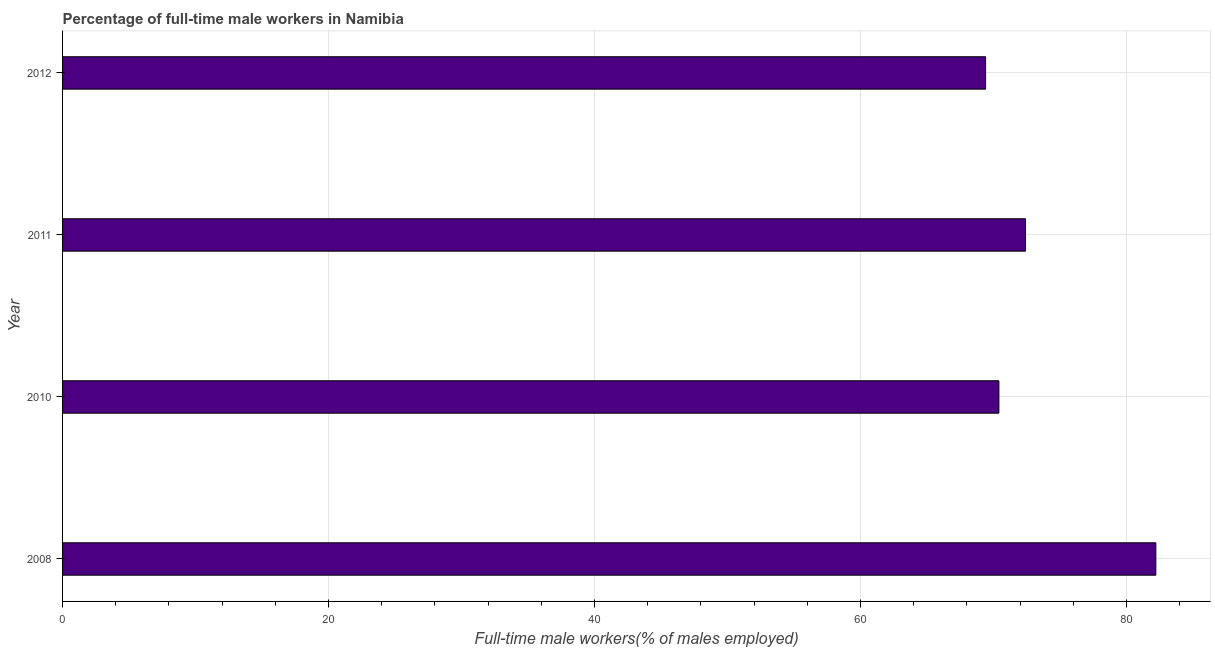Does the graph contain any zero values?
Keep it short and to the point. No. What is the title of the graph?
Make the answer very short. Percentage of full-time male workers in Namibia. What is the label or title of the X-axis?
Your response must be concise. Full-time male workers(% of males employed). What is the percentage of full-time male workers in 2012?
Make the answer very short. 69.4. Across all years, what is the maximum percentage of full-time male workers?
Ensure brevity in your answer.  82.2. Across all years, what is the minimum percentage of full-time male workers?
Provide a short and direct response. 69.4. In which year was the percentage of full-time male workers maximum?
Offer a very short reply. 2008. In which year was the percentage of full-time male workers minimum?
Give a very brief answer. 2012. What is the sum of the percentage of full-time male workers?
Offer a terse response. 294.4. What is the average percentage of full-time male workers per year?
Give a very brief answer. 73.6. What is the median percentage of full-time male workers?
Your answer should be very brief. 71.4. Is the percentage of full-time male workers in 2010 less than that in 2011?
Your answer should be very brief. Yes. What is the difference between the highest and the second highest percentage of full-time male workers?
Offer a terse response. 9.8. What is the difference between the highest and the lowest percentage of full-time male workers?
Give a very brief answer. 12.8. How many bars are there?
Provide a succinct answer. 4. How many years are there in the graph?
Your answer should be very brief. 4. What is the difference between two consecutive major ticks on the X-axis?
Keep it short and to the point. 20. What is the Full-time male workers(% of males employed) in 2008?
Make the answer very short. 82.2. What is the Full-time male workers(% of males employed) of 2010?
Your answer should be compact. 70.4. What is the Full-time male workers(% of males employed) of 2011?
Your response must be concise. 72.4. What is the Full-time male workers(% of males employed) in 2012?
Offer a terse response. 69.4. What is the difference between the Full-time male workers(% of males employed) in 2008 and 2010?
Provide a short and direct response. 11.8. What is the difference between the Full-time male workers(% of males employed) in 2008 and 2012?
Offer a terse response. 12.8. What is the difference between the Full-time male workers(% of males employed) in 2010 and 2011?
Your answer should be very brief. -2. What is the difference between the Full-time male workers(% of males employed) in 2011 and 2012?
Ensure brevity in your answer.  3. What is the ratio of the Full-time male workers(% of males employed) in 2008 to that in 2010?
Give a very brief answer. 1.17. What is the ratio of the Full-time male workers(% of males employed) in 2008 to that in 2011?
Provide a succinct answer. 1.14. What is the ratio of the Full-time male workers(% of males employed) in 2008 to that in 2012?
Keep it short and to the point. 1.18. What is the ratio of the Full-time male workers(% of males employed) in 2011 to that in 2012?
Provide a short and direct response. 1.04. 